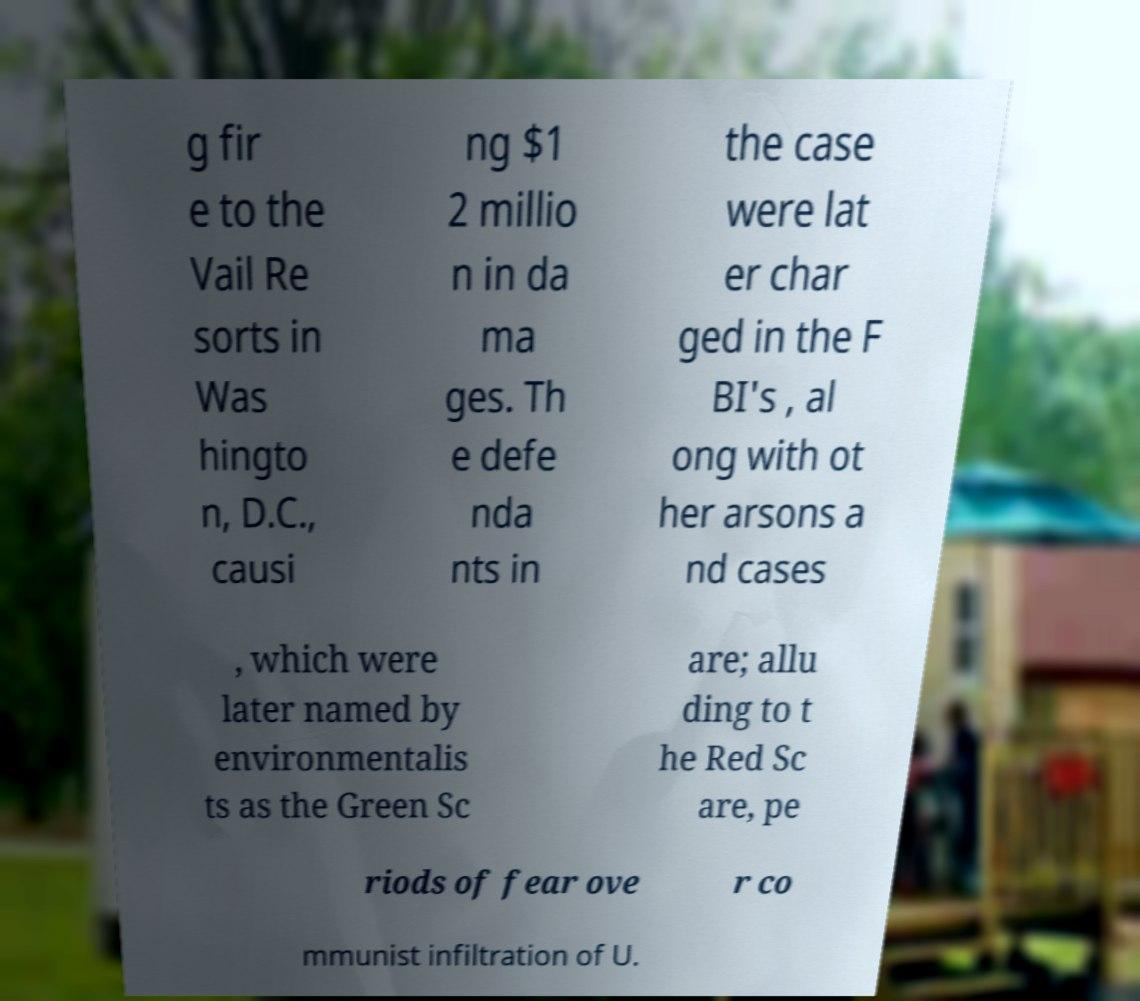Please identify and transcribe the text found in this image. g fir e to the Vail Re sorts in Was hingto n, D.C., causi ng $1 2 millio n in da ma ges. Th e defe nda nts in the case were lat er char ged in the F BI's , al ong with ot her arsons a nd cases , which were later named by environmentalis ts as the Green Sc are; allu ding to t he Red Sc are, pe riods of fear ove r co mmunist infiltration of U. 